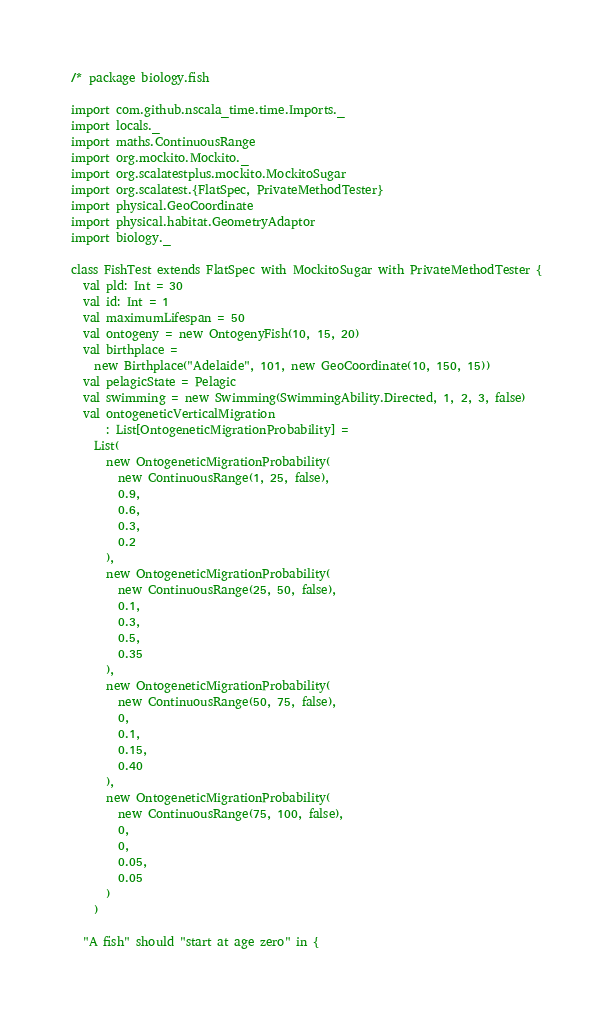Convert code to text. <code><loc_0><loc_0><loc_500><loc_500><_Scala_>/* package biology.fish

import com.github.nscala_time.time.Imports._
import locals._
import maths.ContinuousRange
import org.mockito.Mockito._
import org.scalatestplus.mockito.MockitoSugar
import org.scalatest.{FlatSpec, PrivateMethodTester}
import physical.GeoCoordinate
import physical.habitat.GeometryAdaptor
import biology._

class FishTest extends FlatSpec with MockitoSugar with PrivateMethodTester {
  val pld: Int = 30
  val id: Int = 1
  val maximumLifespan = 50
  val ontogeny = new OntogenyFish(10, 15, 20)
  val birthplace =
    new Birthplace("Adelaide", 101, new GeoCoordinate(10, 150, 15))
  val pelagicState = Pelagic
  val swimming = new Swimming(SwimmingAbility.Directed, 1, 2, 3, false)
  val ontogeneticVerticalMigration
      : List[OntogeneticMigrationProbability] =
    List(
      new OntogeneticMigrationProbability(
        new ContinuousRange(1, 25, false),
        0.9,
        0.6,
        0.3,
        0.2
      ),
      new OntogeneticMigrationProbability(
        new ContinuousRange(25, 50, false),
        0.1,
        0.3,
        0.5,
        0.35
      ),
      new OntogeneticMigrationProbability(
        new ContinuousRange(50, 75, false),
        0,
        0.1,
        0.15,
        0.40
      ),
      new OntogeneticMigrationProbability(
        new ContinuousRange(75, 100, false),
        0,
        0,
        0.05,
        0.05
      )
    )

  "A fish" should "start at age zero" in {</code> 